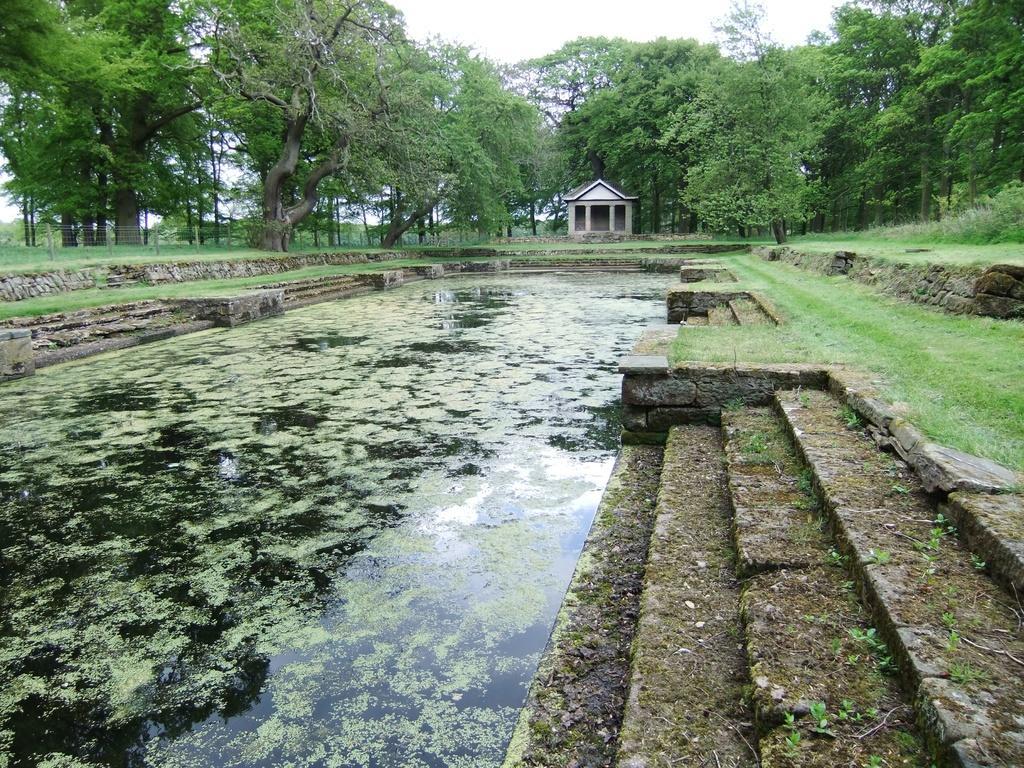Describe this image in one or two sentences. In the center of the image we can see pond. In the background there is a shed and trees. On the left we can see a fence. There are stairs. At the top we can see sky. 